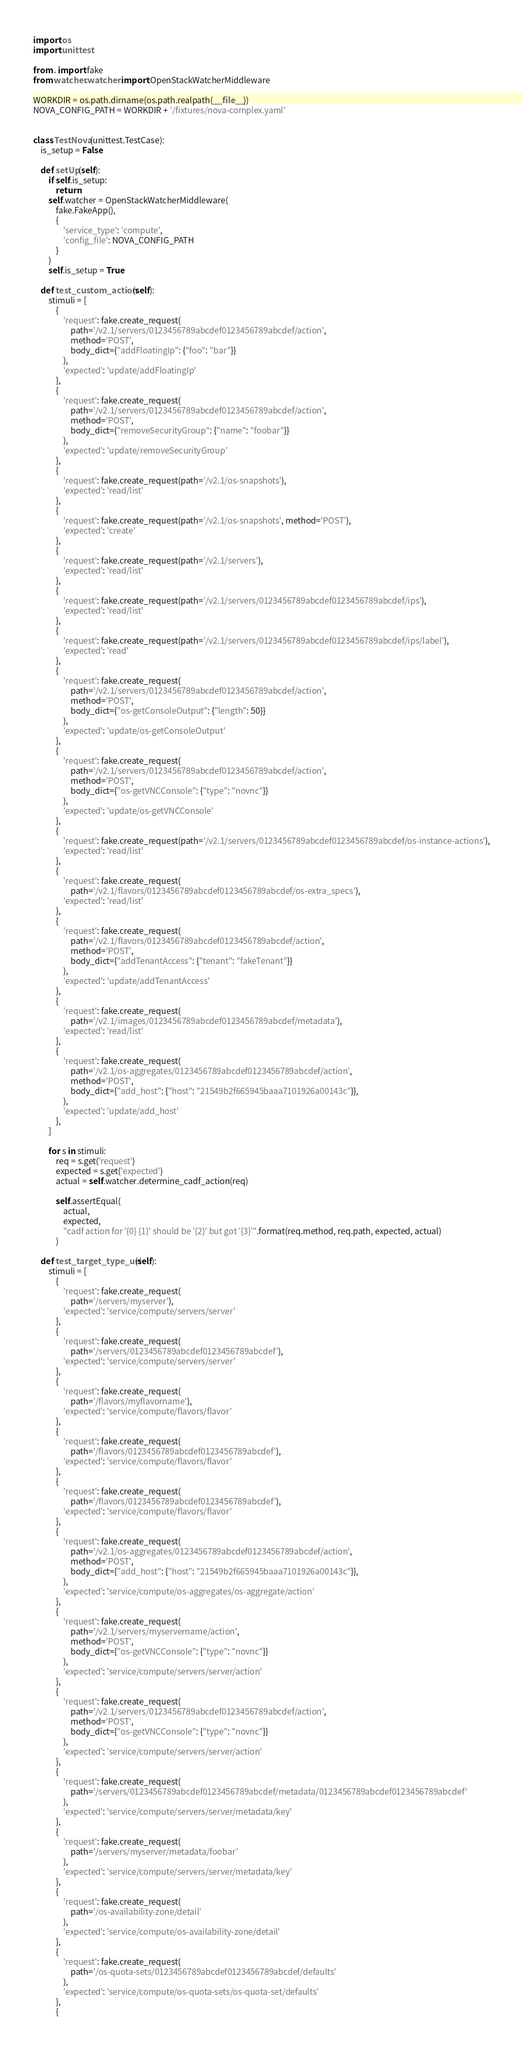Convert code to text. <code><loc_0><loc_0><loc_500><loc_500><_Python_>import os
import unittest

from . import fake
from watcher.watcher import OpenStackWatcherMiddleware

WORKDIR = os.path.dirname(os.path.realpath(__file__))
NOVA_CONFIG_PATH = WORKDIR + '/fixtures/nova-complex.yaml'


class TestNova(unittest.TestCase):
    is_setup = False

    def setUp(self):
        if self.is_setup:
            return
        self.watcher = OpenStackWatcherMiddleware(
            fake.FakeApp(),
            {
                'service_type': 'compute',
                'config_file': NOVA_CONFIG_PATH
            }
        )
        self.is_setup = True

    def test_custom_action(self):
        stimuli = [
            {
                'request': fake.create_request(
                    path='/v2.1/servers/0123456789abcdef0123456789abcdef/action',
                    method='POST',
                    body_dict={"addFloatingIp": {"foo": "bar"}}
                ),
                'expected': 'update/addFloatingIp'
            },
            {
                'request': fake.create_request(
                    path='/v2.1/servers/0123456789abcdef0123456789abcdef/action',
                    method='POST',
                    body_dict={"removeSecurityGroup": {"name": "foobar"}}
                ),
                'expected': 'update/removeSecurityGroup'
            },
            {
                'request': fake.create_request(path='/v2.1/os-snapshots'),
                'expected': 'read/list'
            },
            {
                'request': fake.create_request(path='/v2.1/os-snapshots', method='POST'),
                'expected': 'create'
            },
            {
                'request': fake.create_request(path='/v2.1/servers'),
                'expected': 'read/list'
            },
            {
                'request': fake.create_request(path='/v2.1/servers/0123456789abcdef0123456789abcdef/ips'),
                'expected': 'read/list'
            },
            {
                'request': fake.create_request(path='/v2.1/servers/0123456789abcdef0123456789abcdef/ips/label'),
                'expected': 'read'
            },
            {
                'request': fake.create_request(
                    path='/v2.1/servers/0123456789abcdef0123456789abcdef/action',
                    method='POST',
                    body_dict={"os-getConsoleOutput": {"length": 50}}
                ),
                'expected': 'update/os-getConsoleOutput'
            },
            {
                'request': fake.create_request(
                    path='/v2.1/servers/0123456789abcdef0123456789abcdef/action',
                    method='POST',
                    body_dict={"os-getVNCConsole": {"type": "novnc"}}
                ),
                'expected': 'update/os-getVNCConsole'
            },
            {
                'request': fake.create_request(path='/v2.1/servers/0123456789abcdef0123456789abcdef/os-instance-actions'),
                'expected': 'read/list'
            },
            {
                'request': fake.create_request(
                    path='/v2.1/flavors/0123456789abcdef0123456789abcdef/os-extra_specs'),
                'expected': 'read/list'
            },
            {
                'request': fake.create_request(
                    path='/v2.1/flavors/0123456789abcdef0123456789abcdef/action',
                    method='POST',
                    body_dict={"addTenantAccess": {"tenant": "fakeTenant"}}
                ),
                'expected': 'update/addTenantAccess'
            },
            {
                'request': fake.create_request(
                    path='/v2.1/images/0123456789abcdef0123456789abcdef/metadata'),
                'expected': 'read/list'
            },
            {
                'request': fake.create_request(
                    path='/v2.1/os-aggregates/0123456789abcdef0123456789abcdef/action',
                    method='POST',
                    body_dict={"add_host": {"host": "21549b2f665945baaa7101926a00143c"}},
                ),
                'expected': 'update/add_host'
            },
        ]

        for s in stimuli:
            req = s.get('request')
            expected = s.get('expected')
            actual = self.watcher.determine_cadf_action(req)

            self.assertEqual(
                actual,
                expected,
                "cadf action for '{0} {1}' should be '{2}' but got '{3}'".format(req.method, req.path, expected, actual)
            )

    def test_target_type_uri(self):
        stimuli = [
            {
                'request': fake.create_request(
                    path='/servers/myserver'),
                'expected': 'service/compute/servers/server'
            },
            {
                'request': fake.create_request(
                    path='/servers/0123456789abcdef0123456789abcdef'),
                'expected': 'service/compute/servers/server'
            },
            {
                'request': fake.create_request(
                    path='/flavors/myflavorname'),
                'expected': 'service/compute/flavors/flavor'
            },
            {
                'request': fake.create_request(
                    path='/flavors/0123456789abcdef0123456789abcdef'),
                'expected': 'service/compute/flavors/flavor'
            },
            {
                'request': fake.create_request(
                    path='/flavors/0123456789abcdef0123456789abcdef'),
                'expected': 'service/compute/flavors/flavor'
            },
            {
                'request': fake.create_request(
                    path='/v2.1/os-aggregates/0123456789abcdef0123456789abcdef/action',
                    method='POST',
                    body_dict={"add_host": {"host": "21549b2f665945baaa7101926a00143c"}},
                ),
                'expected': 'service/compute/os-aggregates/os-aggregate/action'
            },
            {
                'request': fake.create_request(
                    path='/v2.1/servers/myservername/action',
                    method='POST',
                    body_dict={"os-getVNCConsole": {"type": "novnc"}}
                ),
                'expected': 'service/compute/servers/server/action'
            },
            {
                'request': fake.create_request(
                    path='/v2.1/servers/0123456789abcdef0123456789abcdef/action',
                    method='POST',
                    body_dict={"os-getVNCConsole": {"type": "novnc"}}
                ),
                'expected': 'service/compute/servers/server/action'
            },
            {
                'request': fake.create_request(
                    path='/servers/0123456789abcdef0123456789abcdef/metadata/0123456789abcdef0123456789abcdef'
                ),
                'expected': 'service/compute/servers/server/metadata/key'
            },
            {
                'request': fake.create_request(
                    path='/servers/myserver/metadata/foobar'
                ),
                'expected': 'service/compute/servers/server/metadata/key'
            },
            {
                'request': fake.create_request(
                    path='/os-availability-zone/detail'
                ),
                'expected': 'service/compute/os-availability-zone/detail'
            },
            {
                'request': fake.create_request(
                    path='/os-quota-sets/0123456789abcdef0123456789abcdef/defaults'
                ),
                'expected': 'service/compute/os-quota-sets/os-quota-set/defaults'
            },
            {</code> 